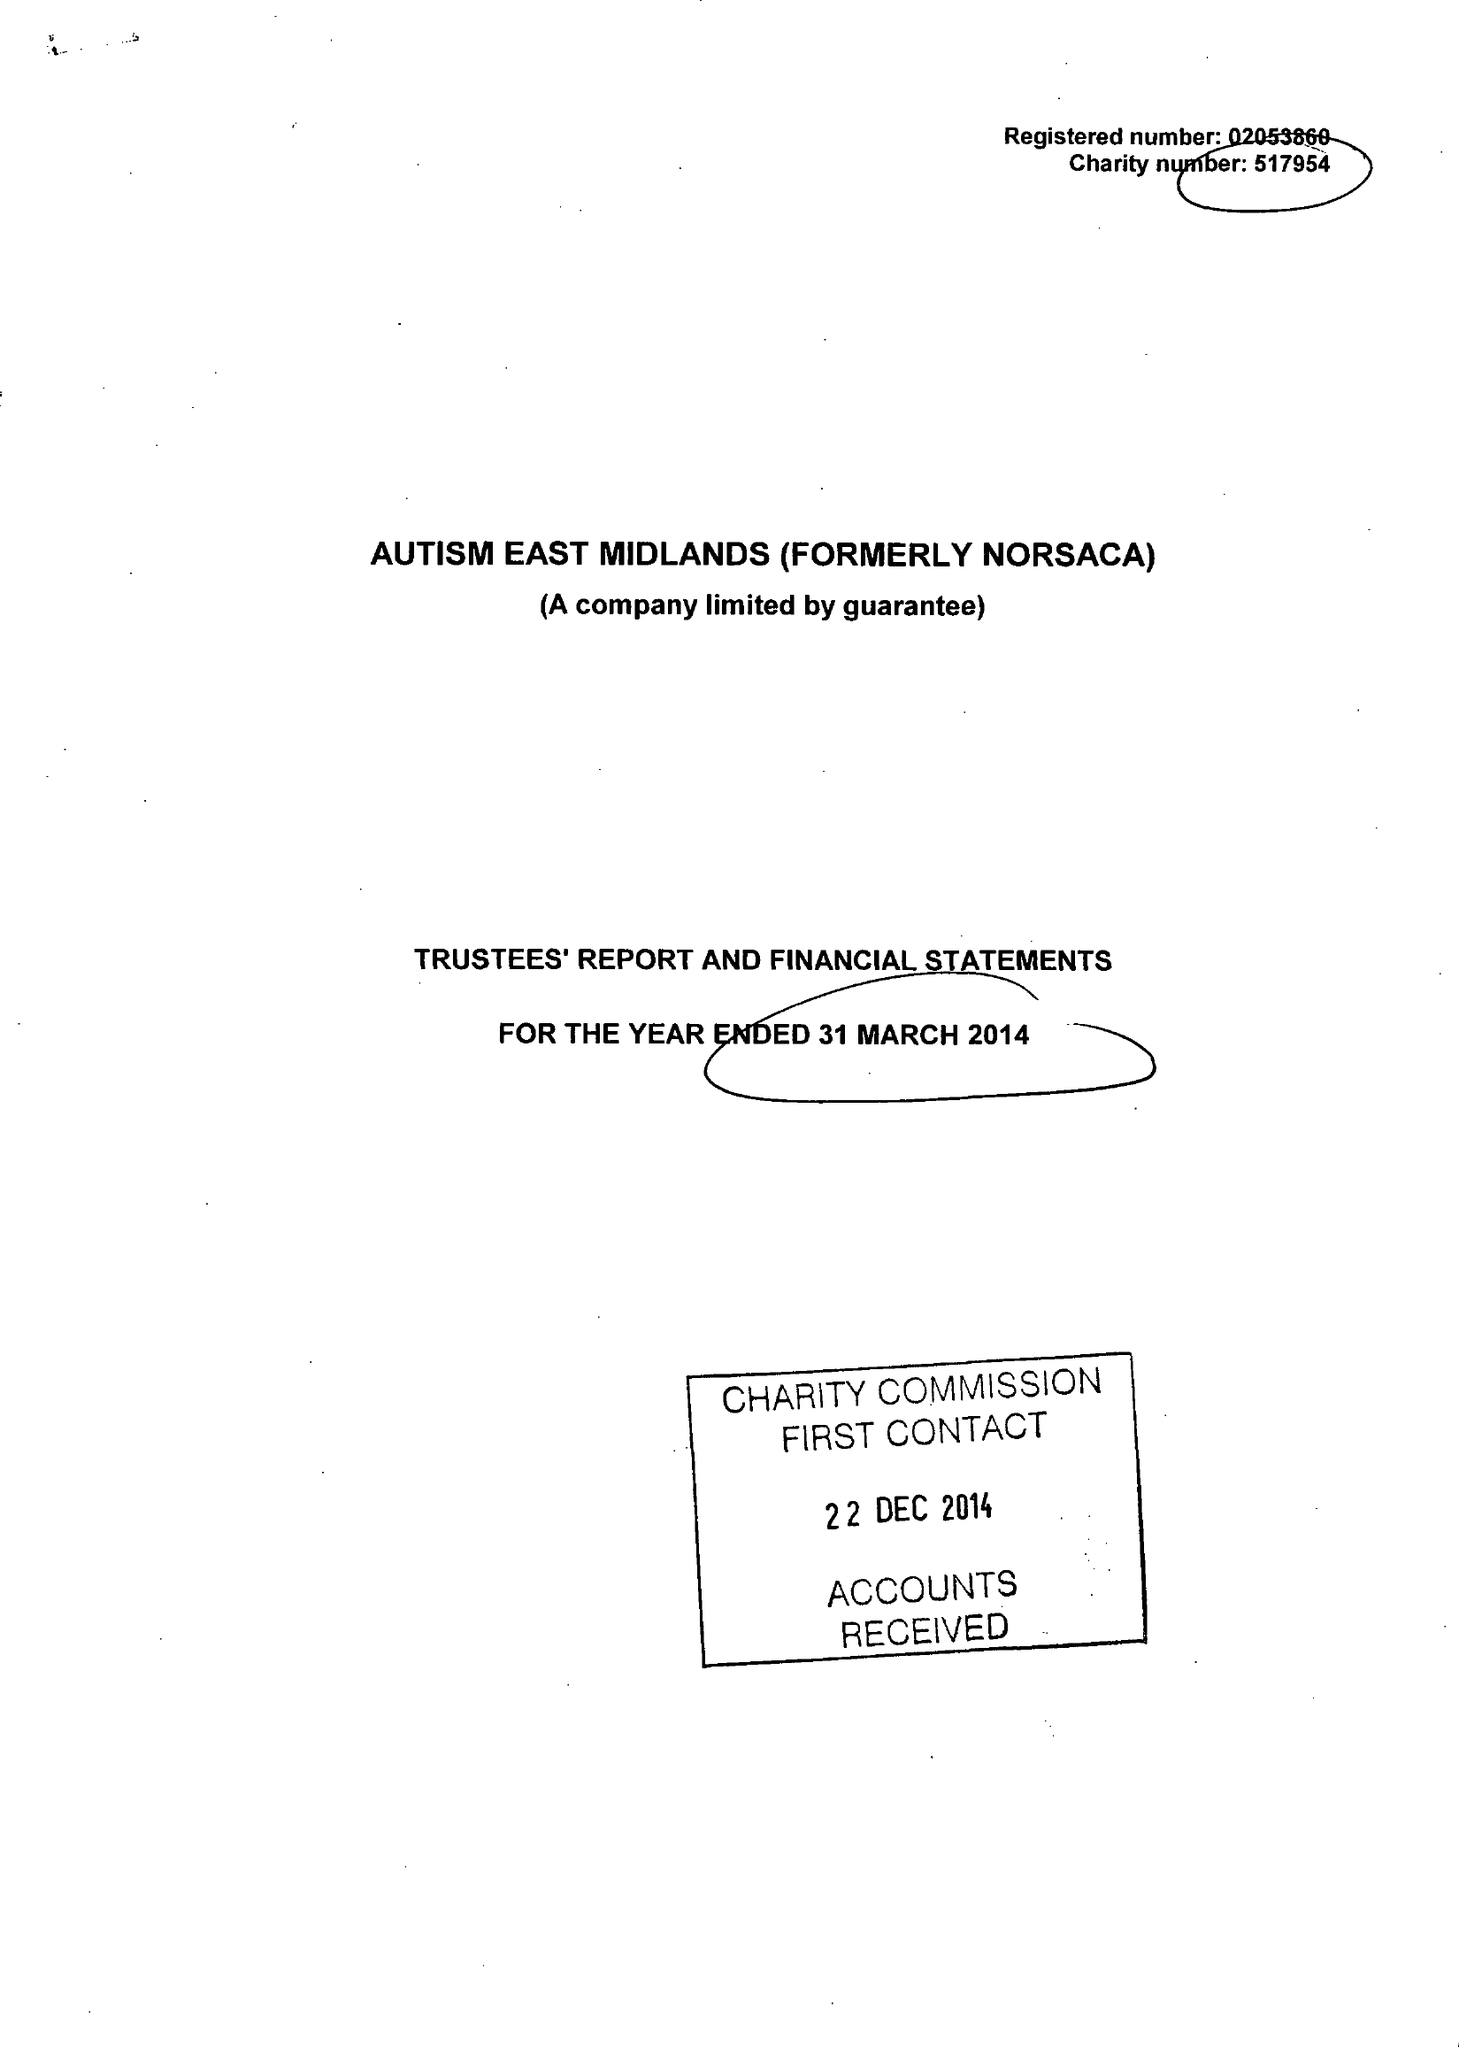What is the value for the charity_number?
Answer the question using a single word or phrase. 517954 